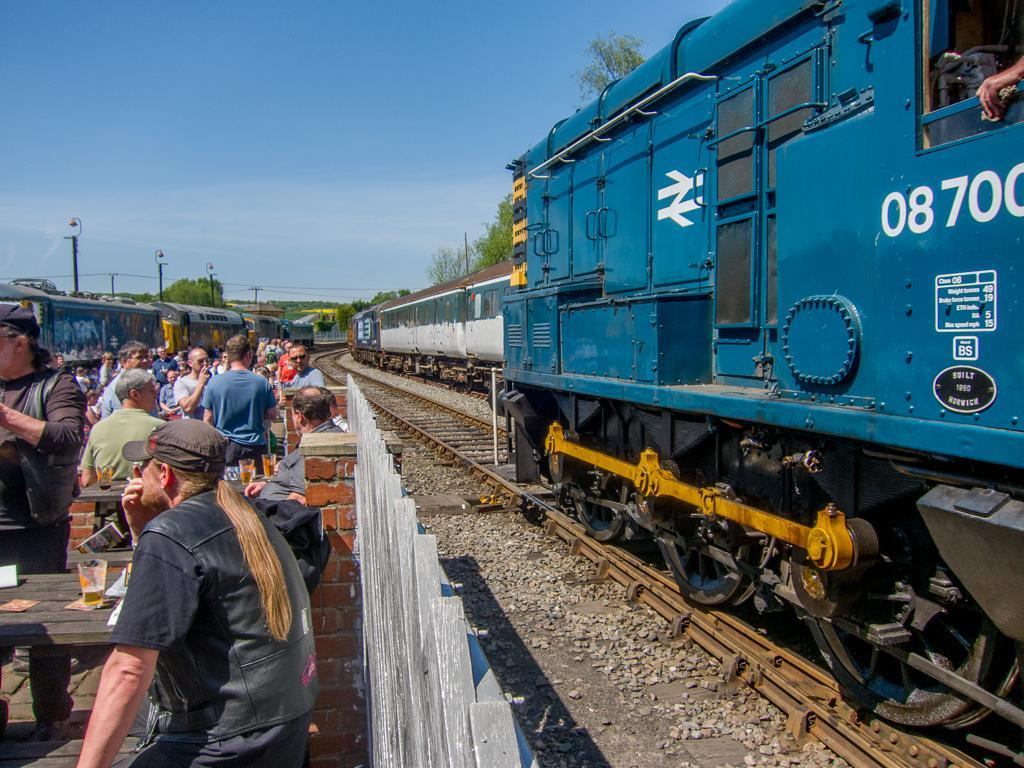<image>
Present a compact description of the photo's key features. Blue locomotive number 08700 going by some bikers at a picnic table. 